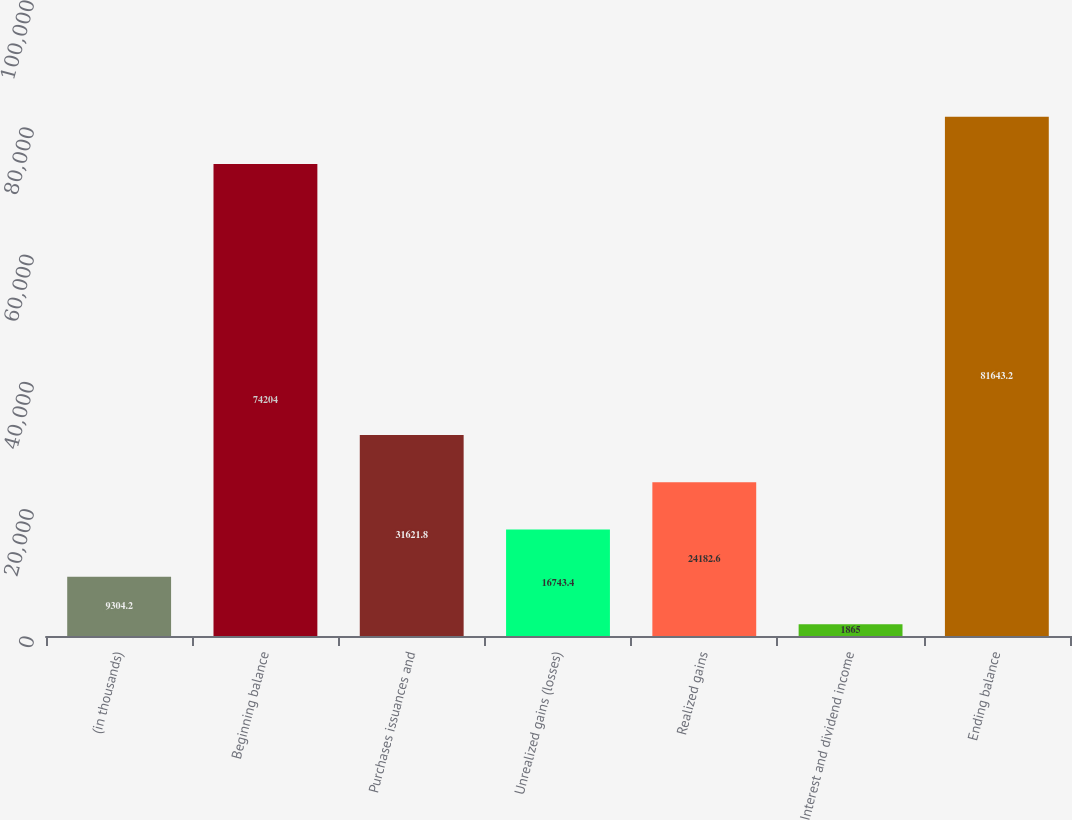<chart> <loc_0><loc_0><loc_500><loc_500><bar_chart><fcel>(in thousands)<fcel>Beginning balance<fcel>Purchases issuances and<fcel>Unrealized gains (losses)<fcel>Realized gains<fcel>Interest and dividend income<fcel>Ending balance<nl><fcel>9304.2<fcel>74204<fcel>31621.8<fcel>16743.4<fcel>24182.6<fcel>1865<fcel>81643.2<nl></chart> 